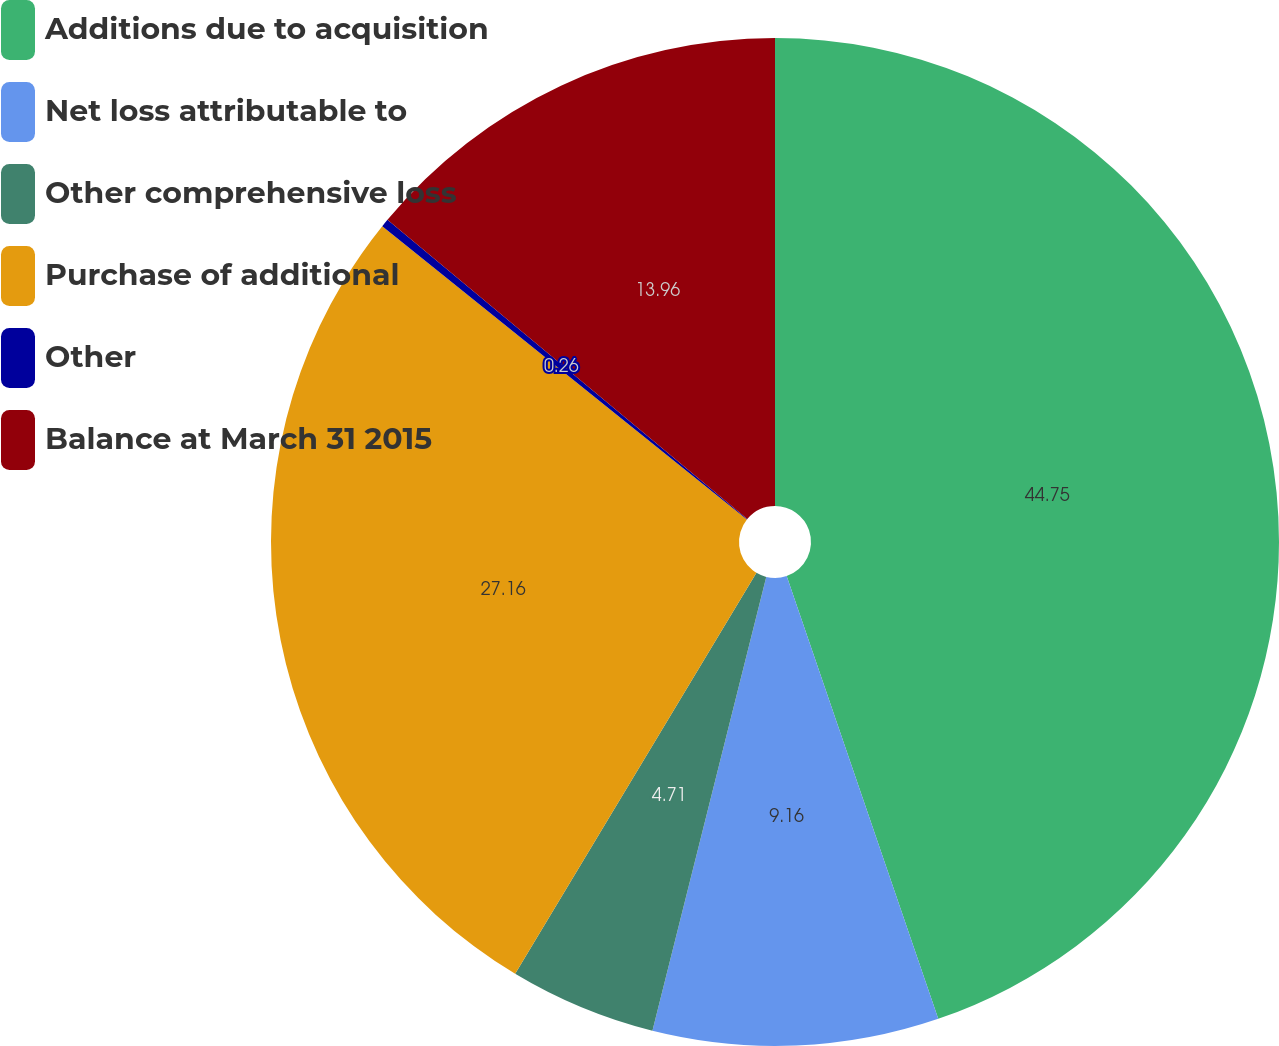Convert chart. <chart><loc_0><loc_0><loc_500><loc_500><pie_chart><fcel>Additions due to acquisition<fcel>Net loss attributable to<fcel>Other comprehensive loss<fcel>Purchase of additional<fcel>Other<fcel>Balance at March 31 2015<nl><fcel>44.75%<fcel>9.16%<fcel>4.71%<fcel>27.16%<fcel>0.26%<fcel>13.96%<nl></chart> 